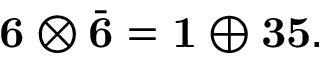<formula> <loc_0><loc_0><loc_500><loc_500>{ 6 } \otimes \bar { 6 } = { 1 } \oplus { 3 5 } .</formula> 